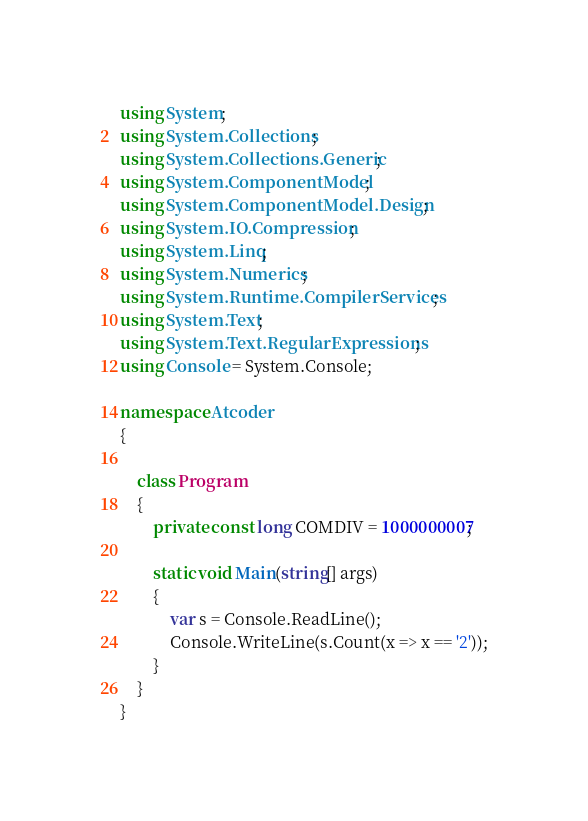Convert code to text. <code><loc_0><loc_0><loc_500><loc_500><_C#_>using System;
using System.Collections;
using System.Collections.Generic;
using System.ComponentModel;
using System.ComponentModel.Design;
using System.IO.Compression;
using System.Linq;
using System.Numerics;
using System.Runtime.CompilerServices;
using System.Text;
using System.Text.RegularExpressions;
using Console = System.Console;

namespace Atcoder
{

    class Program
    {
        private const long COMDIV = 1000000007;

        static void Main(string[] args)
        {
            var s = Console.ReadLine();
            Console.WriteLine(s.Count(x => x == '2'));
        }
    }
}</code> 